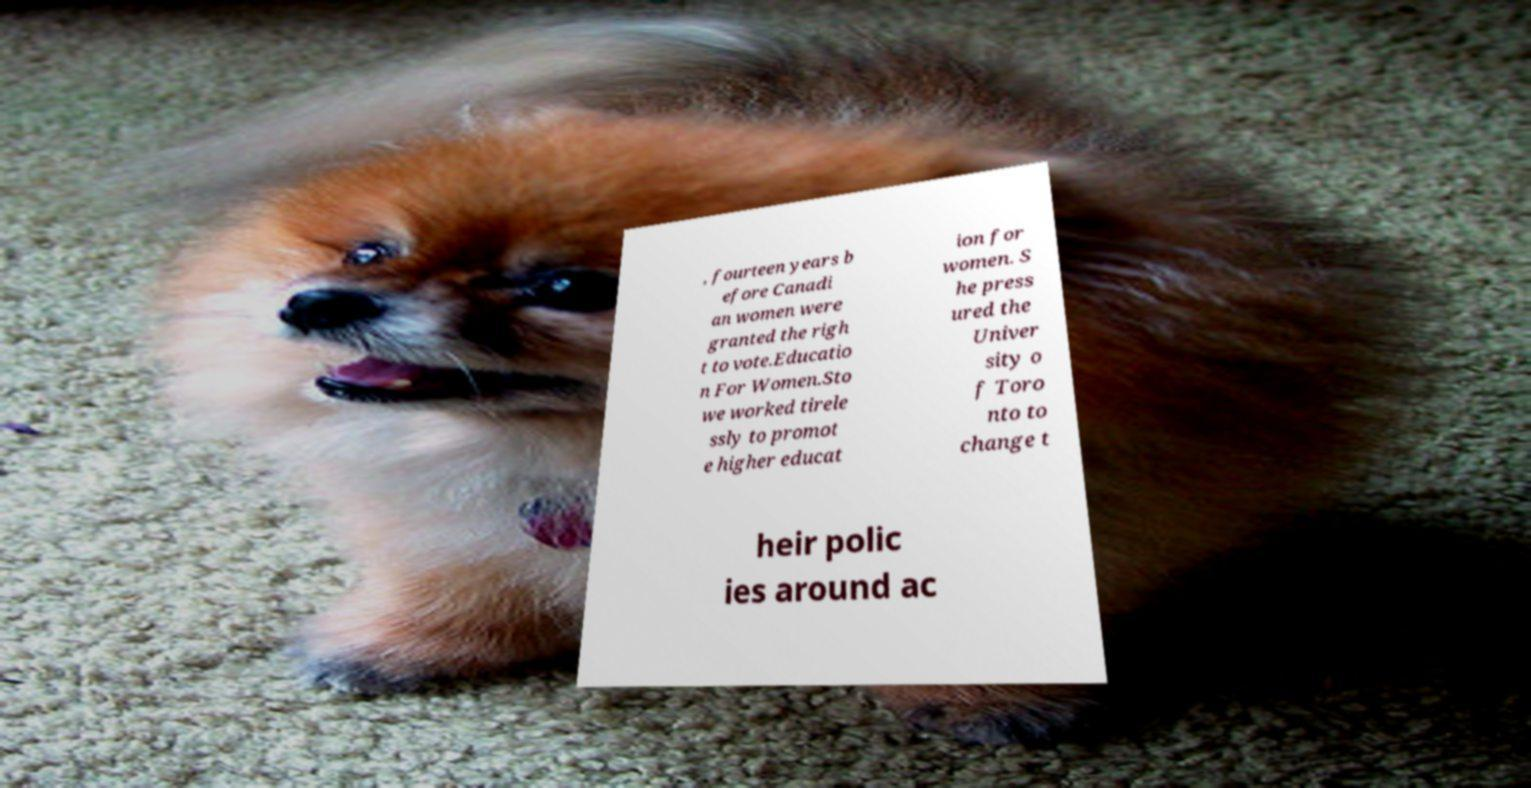Please identify and transcribe the text found in this image. , fourteen years b efore Canadi an women were granted the righ t to vote.Educatio n For Women.Sto we worked tirele ssly to promot e higher educat ion for women. S he press ured the Univer sity o f Toro nto to change t heir polic ies around ac 